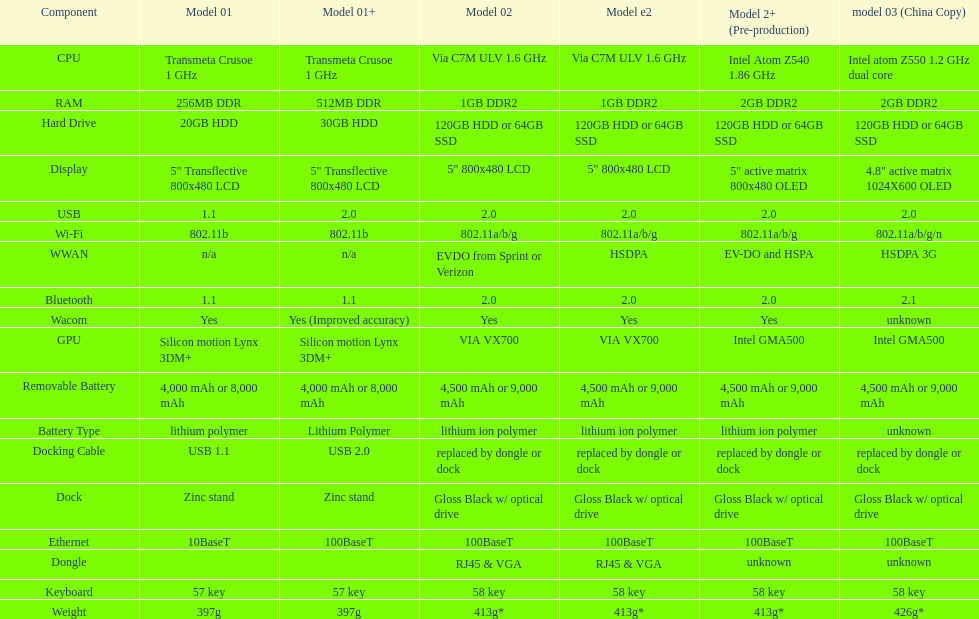How many models use a usb docking cable? 2. 